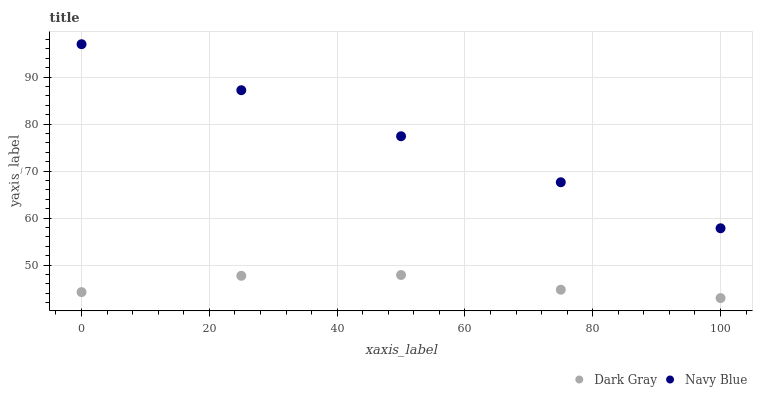Does Dark Gray have the minimum area under the curve?
Answer yes or no. Yes. Does Navy Blue have the maximum area under the curve?
Answer yes or no. Yes. Does Navy Blue have the minimum area under the curve?
Answer yes or no. No. Is Navy Blue the smoothest?
Answer yes or no. Yes. Is Dark Gray the roughest?
Answer yes or no. Yes. Is Navy Blue the roughest?
Answer yes or no. No. Does Dark Gray have the lowest value?
Answer yes or no. Yes. Does Navy Blue have the lowest value?
Answer yes or no. No. Does Navy Blue have the highest value?
Answer yes or no. Yes. Is Dark Gray less than Navy Blue?
Answer yes or no. Yes. Is Navy Blue greater than Dark Gray?
Answer yes or no. Yes. Does Dark Gray intersect Navy Blue?
Answer yes or no. No. 